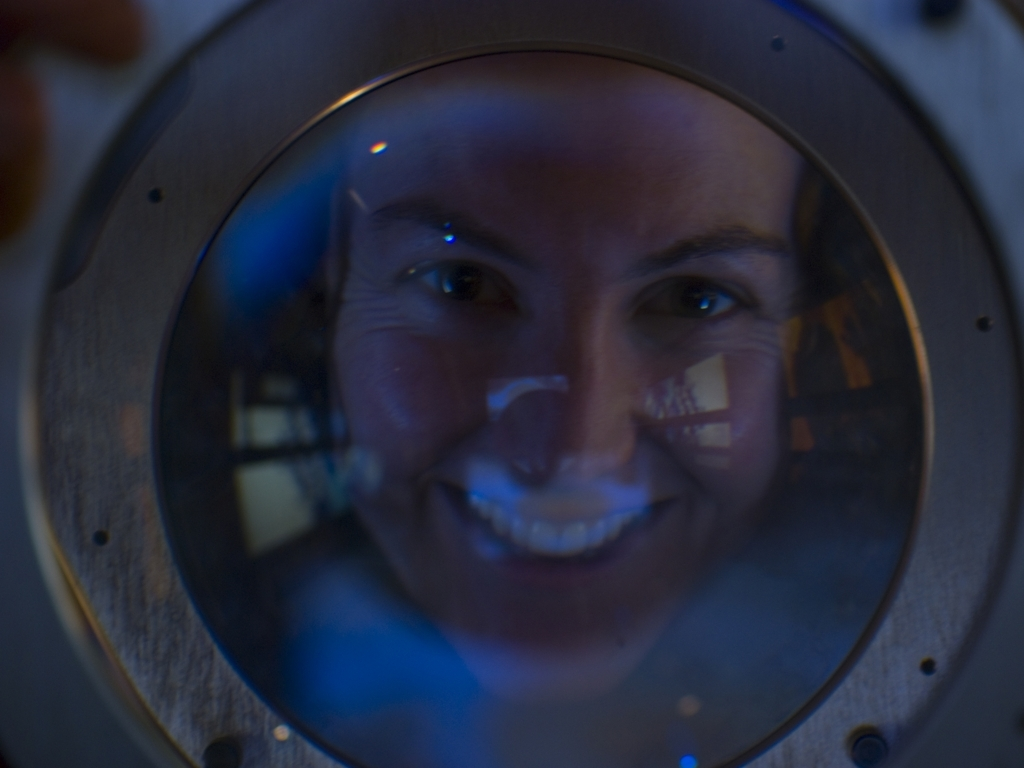How would you describe the lighting in this image? A. Well-lit B. Clear C. Poor D. Bright Answer with the option's letter from the given choices directly. The lighting in this image could be described as 'poor' (C). The subject's face is visible but appears to be in shadow relative to the surrounding areas. There are reflections and some bright spots, but these do not sufficiently illuminate the subject's face to classify the overall lighting as well-lit or bright. 